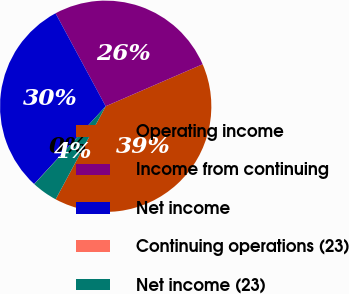Convert chart. <chart><loc_0><loc_0><loc_500><loc_500><pie_chart><fcel>Operating income<fcel>Income from continuing<fcel>Net income<fcel>Continuing operations (23)<fcel>Net income (23)<nl><fcel>39.37%<fcel>26.36%<fcel>30.29%<fcel>0.02%<fcel>3.96%<nl></chart> 